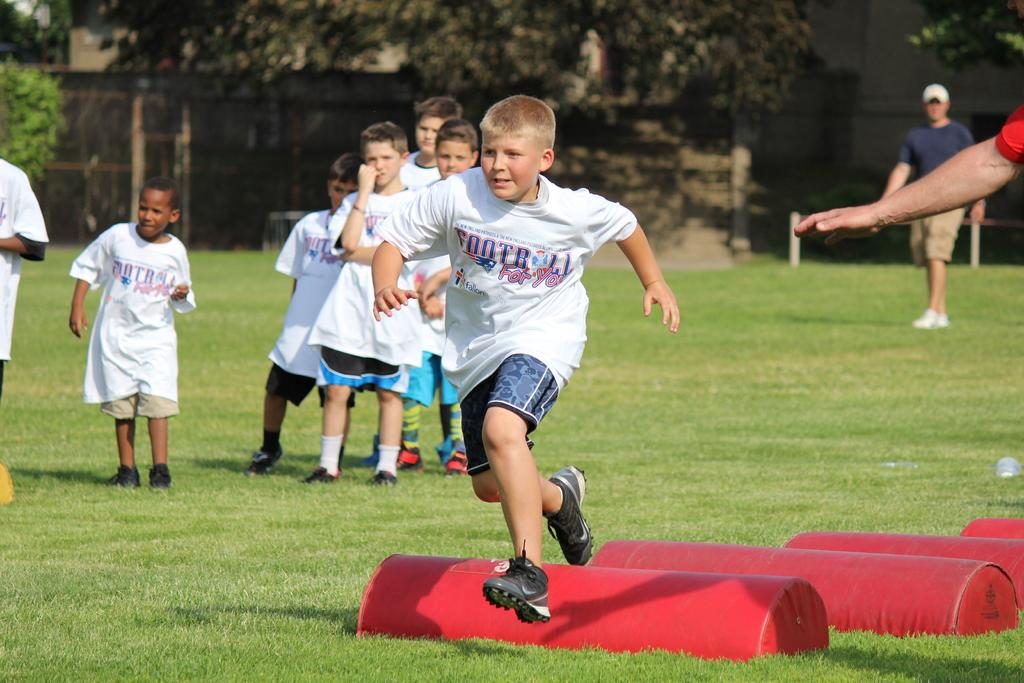Where was the image taken? The image was taken in a playground. What can be seen in the foreground of the picture? There are people and hurdles in the foreground of the picture. What is visible in the background of the picture? There are trees and grass in the background of the picture, as well as a person. What is present at the bottom of the image? Grass is present at the bottom of the image. What type of copper material can be seen being destroyed in the image? There is no copper material or destruction present in the image. What color of paint is being used on the trees in the background of the image? The trees in the background are not being painted, and there is no mention of paint in the image. 